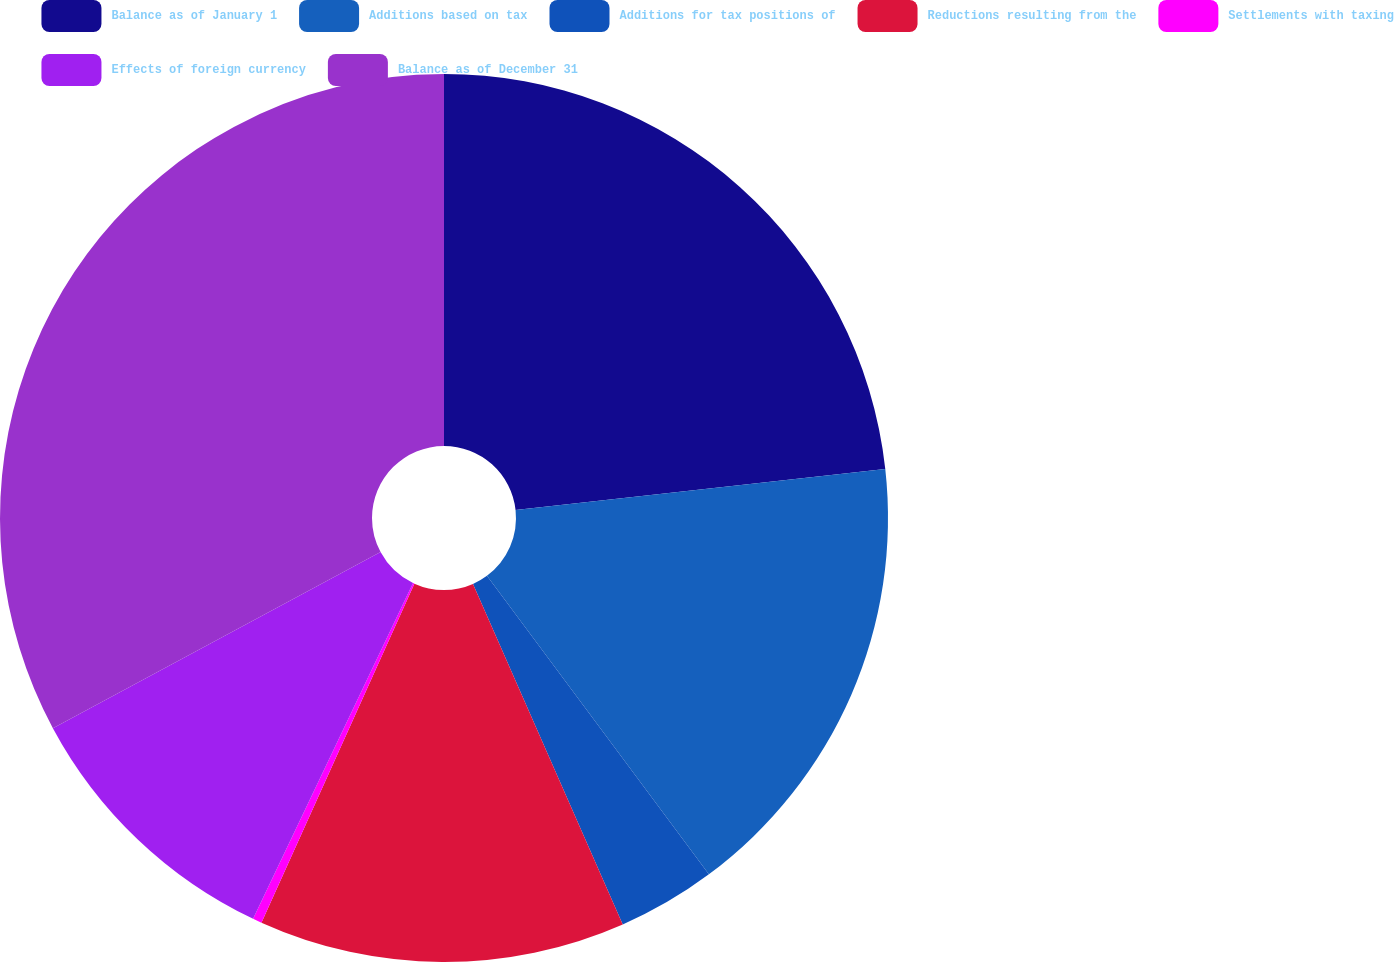<chart> <loc_0><loc_0><loc_500><loc_500><pie_chart><fcel>Balance as of January 1<fcel>Additions based on tax<fcel>Additions for tax positions of<fcel>Reductions resulting from the<fcel>Settlements with taxing<fcel>Effects of foreign currency<fcel>Balance as of December 31<nl><fcel>23.24%<fcel>16.59%<fcel>3.58%<fcel>13.34%<fcel>0.33%<fcel>10.08%<fcel>32.85%<nl></chart> 